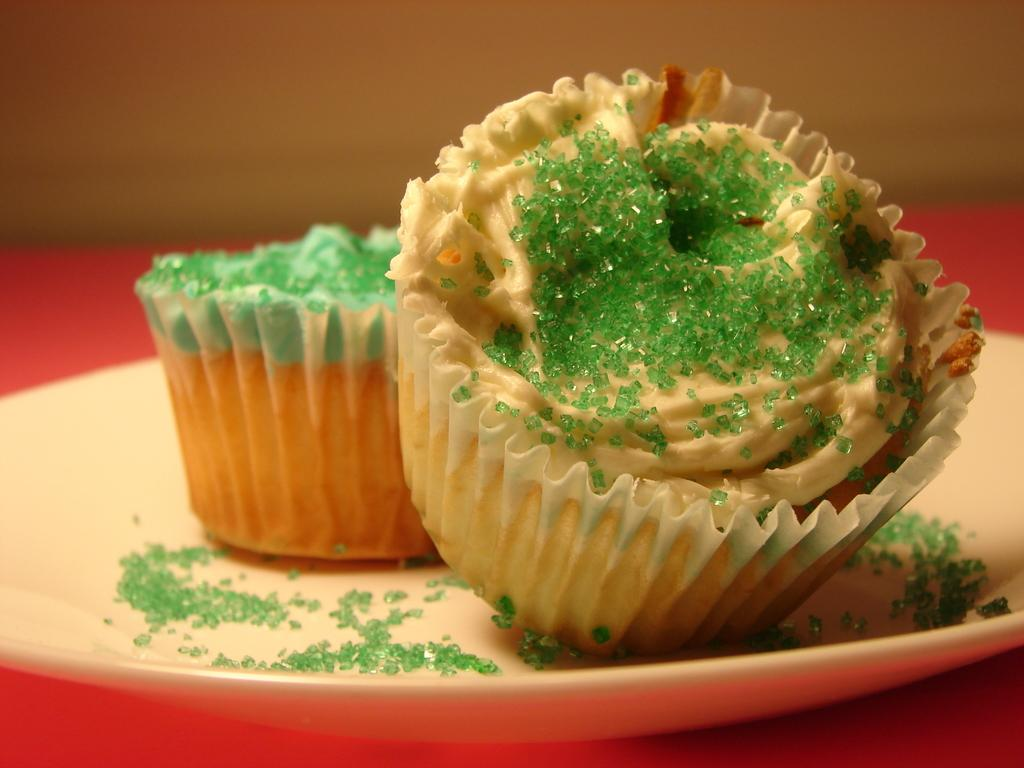How many cupcakes are visible in the image? There are two cupcakes in the image. Where are the cupcakes placed? The cupcakes are on a plate. What is the plate resting on? The plate is on a table. Can you describe the location of the table in relation to other objects? The table is near a wall. What color is the underwear worn by the cupcakes in the image? There are no cupcakes wearing underwear in the image, as cupcakes are not living beings and do not wear clothing. 